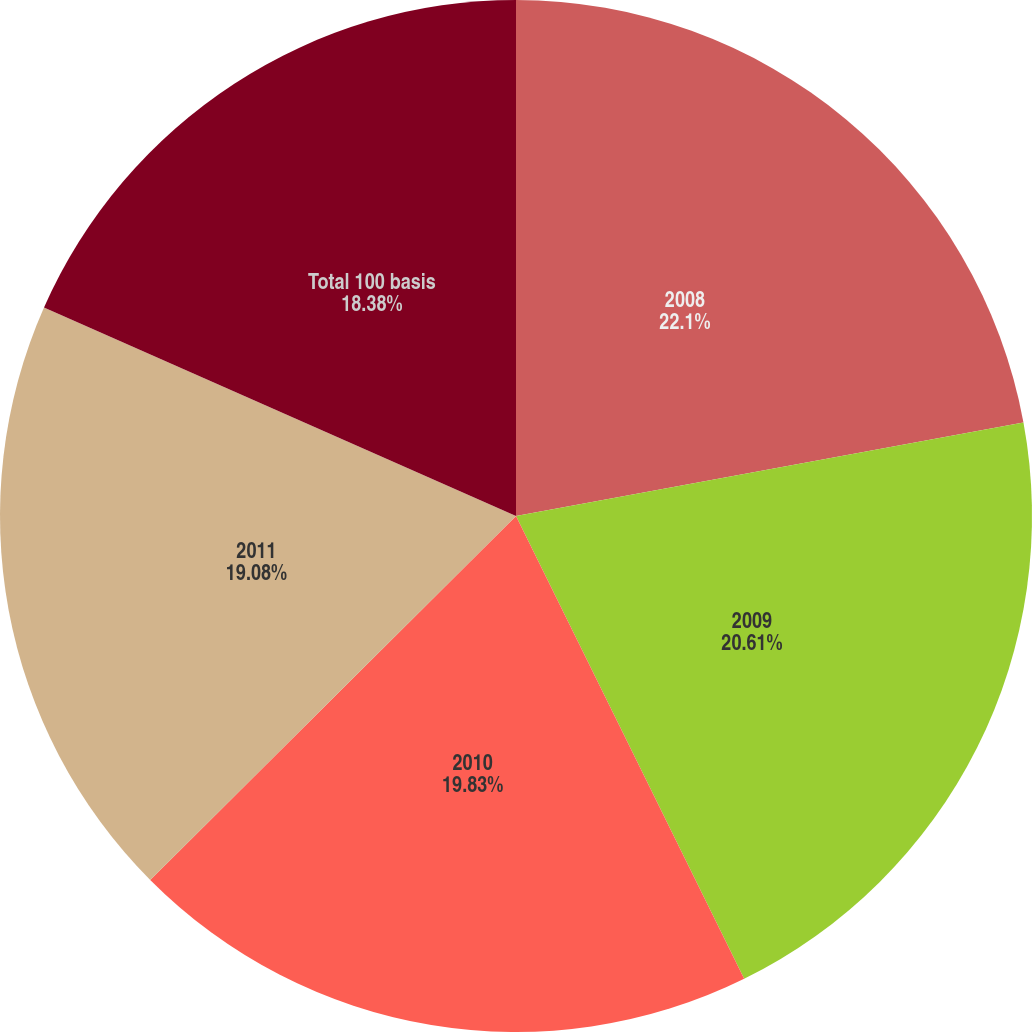<chart> <loc_0><loc_0><loc_500><loc_500><pie_chart><fcel>2008<fcel>2009<fcel>2010<fcel>2011<fcel>Total 100 basis<nl><fcel>22.1%<fcel>20.61%<fcel>19.83%<fcel>19.08%<fcel>18.38%<nl></chart> 